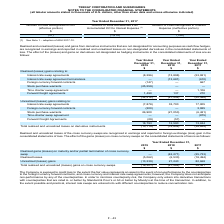According to Teekay Corporation's financial document, How are the realized and unrealized losses recognized? in earnings and reported in foreign exchange (loss) gain in the consolidated statements of loss.. The document states: "losses of the cross currency swaps are recognized in earnings and reported in foreign exchange (loss) gain in the consolidated statements of loss. The..." Also, What were the Realized losses in 2019, 2018 and 2017 respectively? The document contains multiple relevant values: (5,062), (6,533), (18,494) (in thousands). From the document: "Realized losses (5,062) (6,533) (18,494) Realized losses (5,062) (6,533) (18,494) Realized losses (5,062) (6,533) (18,494)..." Also, Why are interest rate swaps entered into with different counterparties? to reduce concentration risk.. The document states: "aps are entered into with different counterparties to reduce concentration risk...." Also, can you calculate: What is the change in the Realized gains (losses) on maturity and/or partial termination of cross currency swap from 2018 to 2019? Based on the calculation: 0 - (-42,271), the result is 42271 (in thousands). This is based on the information: "/or partial termination of cross currency swap — (42,271) (25,733) 2018..." The key data points involved are: 0, 42,271. Also, can you calculate: What was the average realized losses for 2017-2019? To answer this question, I need to perform calculations using the financial data. The calculation is: -(5,062 + 6,533 + 18,494) / 3, which equals -10029.67 (in thousands). This is based on the information: "Realized losses (5,062) (6,533) (18,494) Realized losses (5,062) (6,533) (18,494) Realized losses (5,062) (6,533) (18,494)..." The key data points involved are: 18,494, 5,062, 6,533. Also, can you calculate: What is the percentage change in the Unrealized (losses) gains from 2017 to 2018? To answer this question, I need to perform calculations using the financial data. The calculation is: 21,240 / 82,668 - 1, which equals -74.31 (percentage). This is based on the information: "Unrealized (losses) gains (13,239) 21,240 82,668 Unrealized (losses) gains (13,239) 21,240 82,668..." The key data points involved are: 21,240, 82,668. 